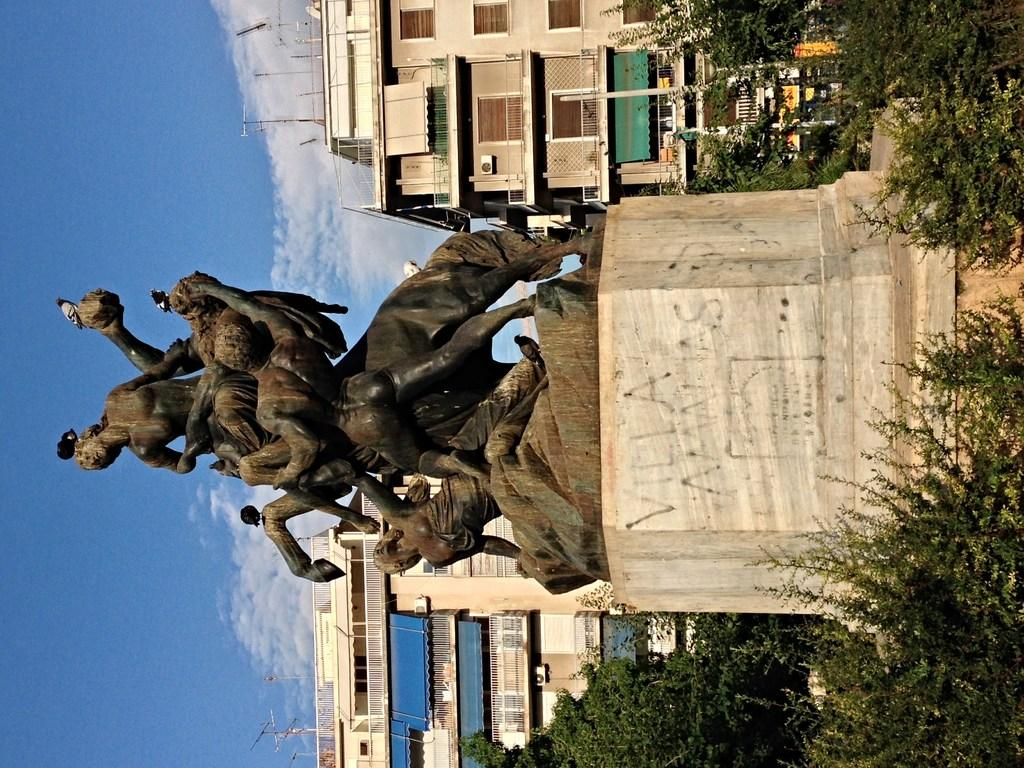What is the main subject on the platform in the image? There is a statue on a platform in the image. What type of natural elements can be seen in the image? Trees are visible in the image. What type of man-made structures can be seen in the image? There are buildings in the image. What other objects can be seen in the image? There are some objects in the image. What is visible in the background of the image? The sky is visible in the background of the image. What can be observed in the sky? Clouds are present in the sky. How does the statue adjust its position using the hook in the image? There is no hook present in the image, and the statue does not adjust its position. 